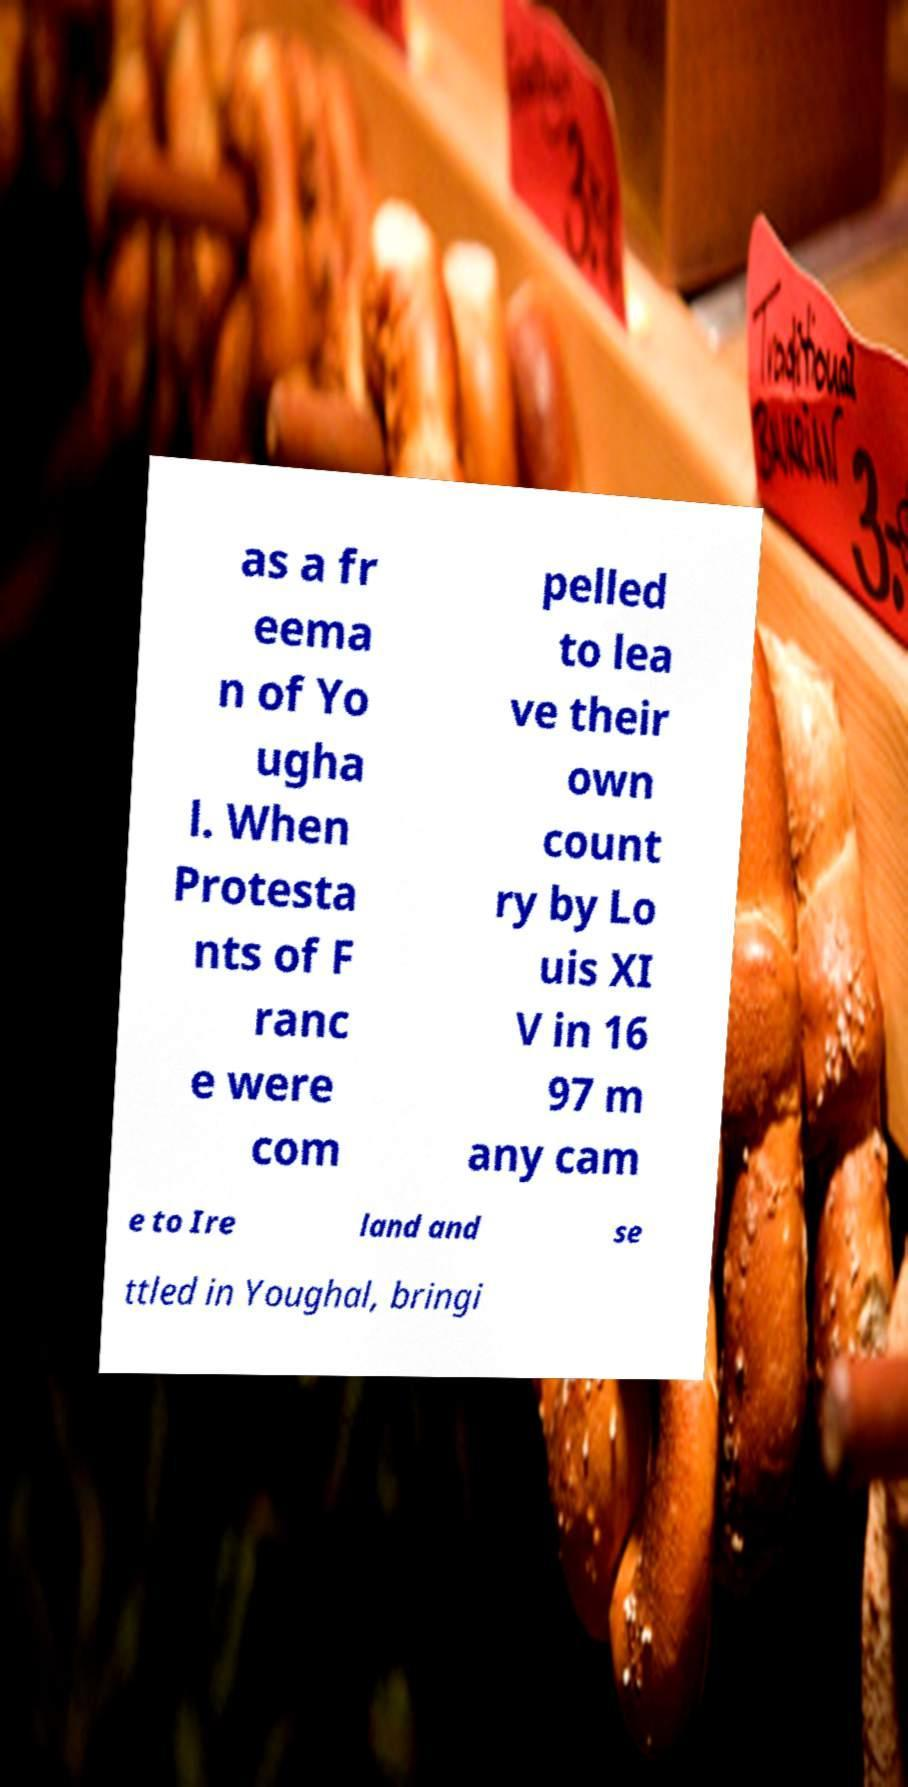What messages or text are displayed in this image? I need them in a readable, typed format. as a fr eema n of Yo ugha l. When Protesta nts of F ranc e were com pelled to lea ve their own count ry by Lo uis XI V in 16 97 m any cam e to Ire land and se ttled in Youghal, bringi 